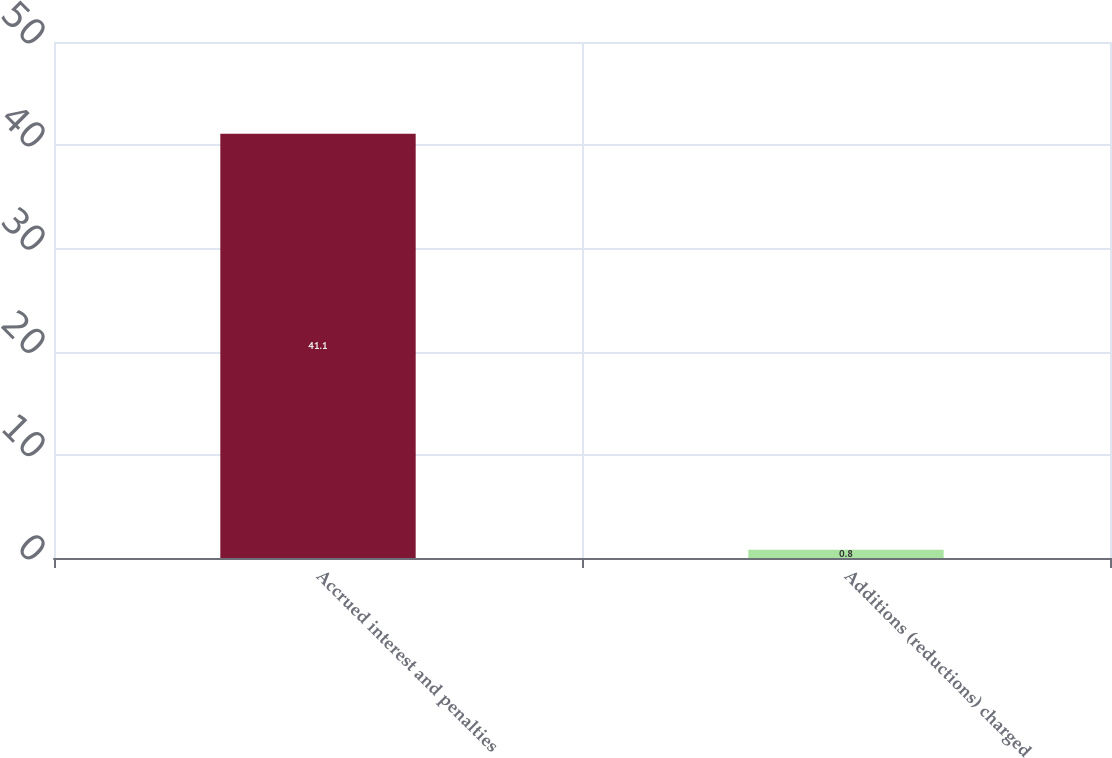<chart> <loc_0><loc_0><loc_500><loc_500><bar_chart><fcel>Accrued interest and penalties<fcel>Additions (reductions) charged<nl><fcel>41.1<fcel>0.8<nl></chart> 